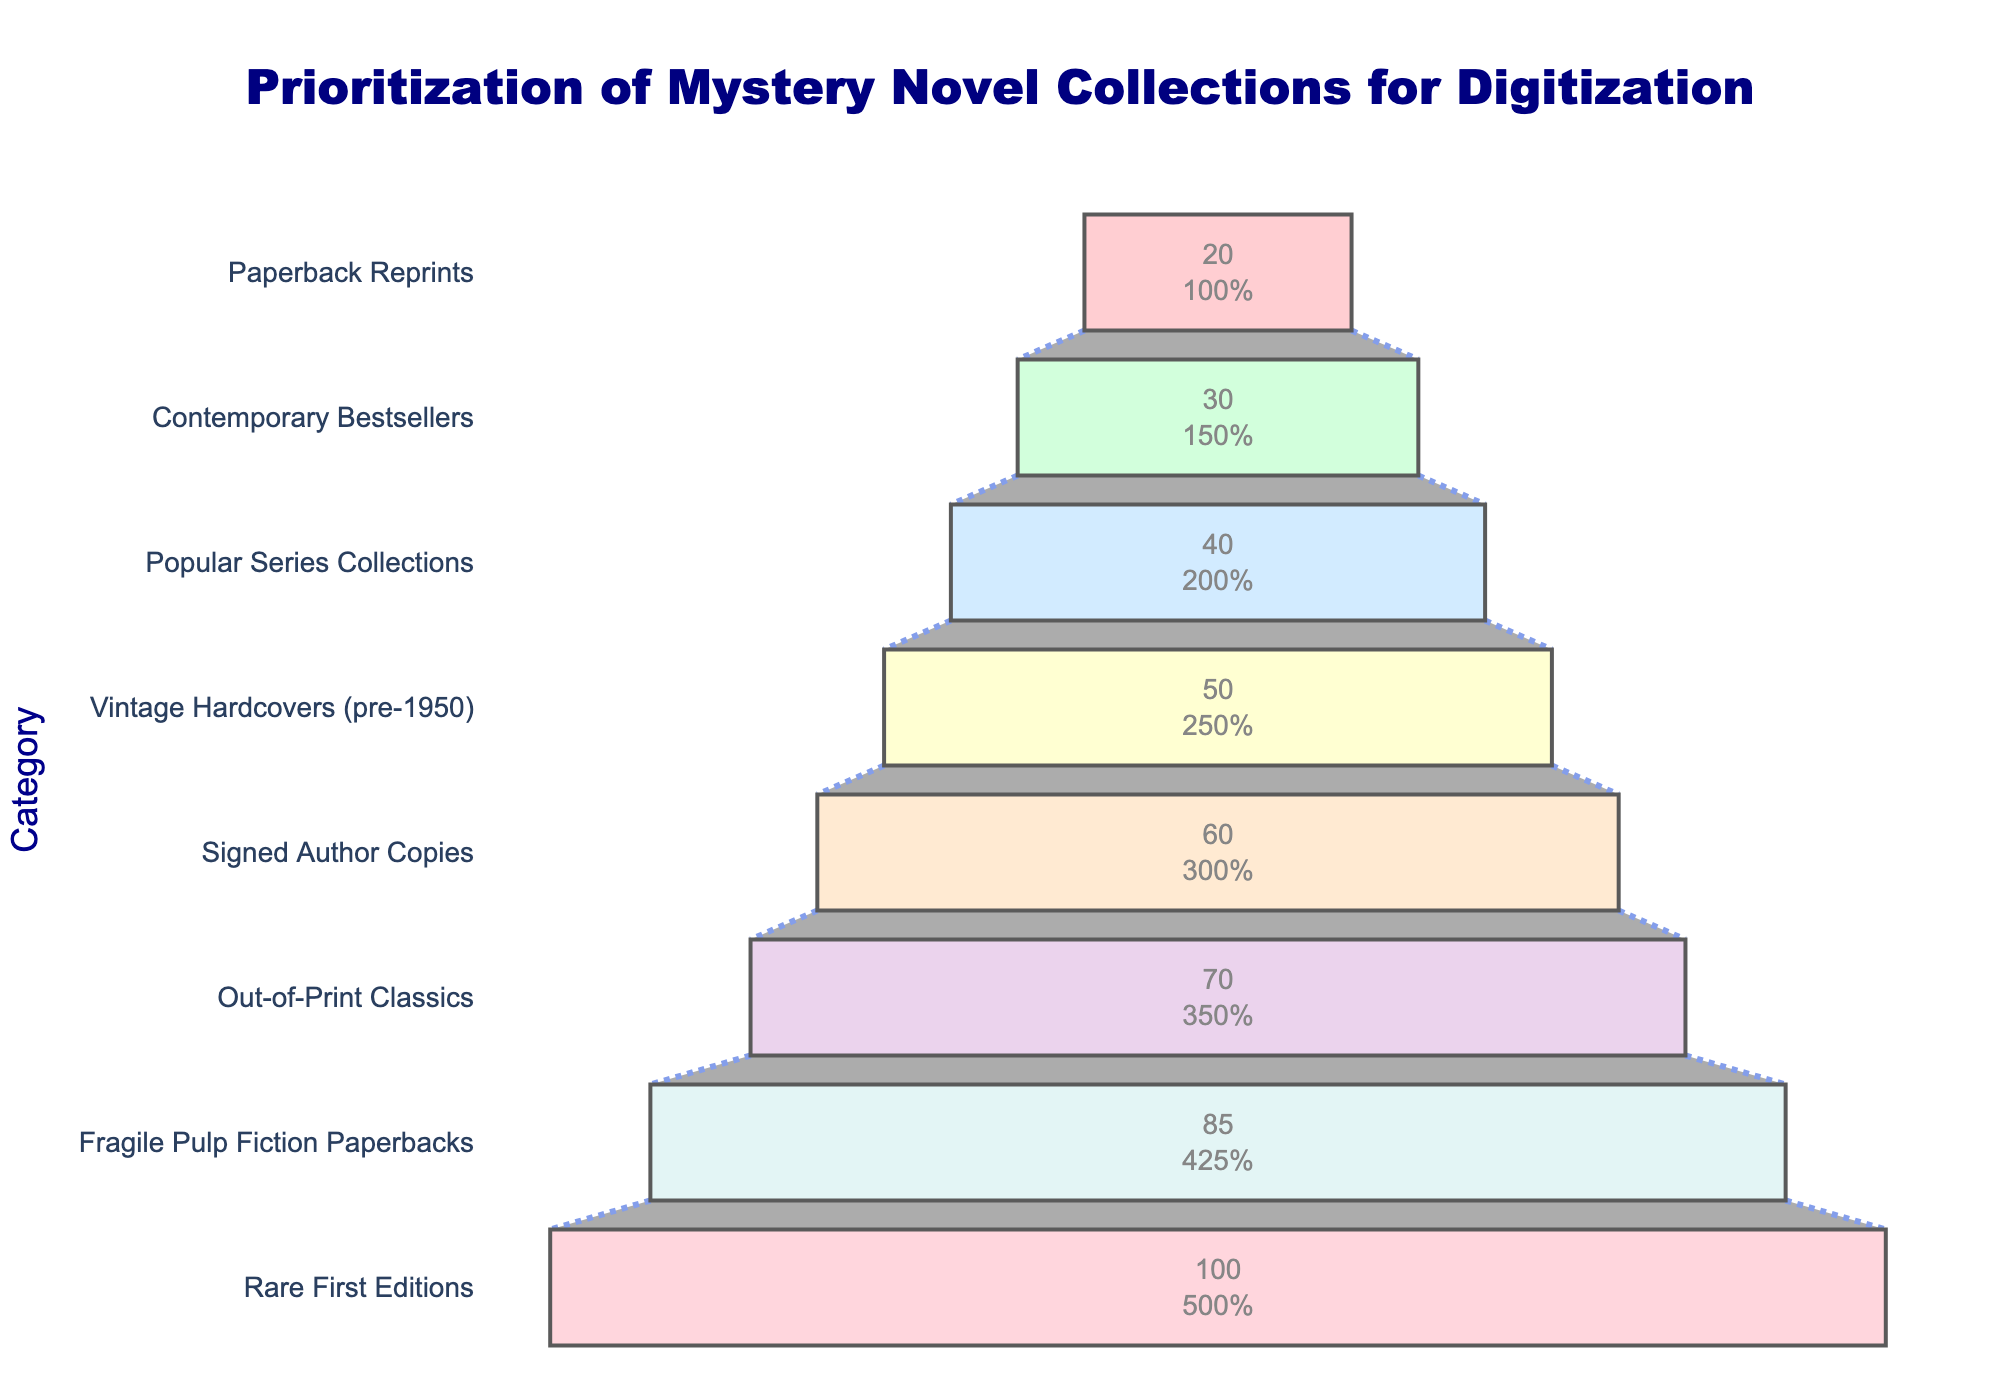What is the title of the funnel chart? The title is usually displayed at the top of the chart. Here, it is clearly written as "Prioritization of Mystery Novel Collections for Digitization."
Answer: Prioritization of Mystery Novel Collections for Digitization How many categories are prioritized in the funnel chart? The number of unique elements along the y-axis represents the number of categories. Each category corresponds to a mystery novel collection type.
Answer: Eight Which category has the highest priority score for digitization? The category at the bottom of the funnel (largest segment) with the highest priority score, clearly displayed on the x-axis.
Answer: Rare First Editions What is the priority score for Contemporary Bestsellers? Locate the segment labeled "Contemporary Bestsellers" in the funnel chart and read the corresponding priority score from the x-axis labels.
Answer: 30 Which category has a priority score of 50? Locate the segment in the funnel with an "x" value of 50 and check the corresponding "y" value, representing the category.
Answer: Vintage Hardcovers (pre-1950) Which has more priority: Signed Author Copies or Popular Series Collections, and by how much? Locate the segments for Signed Author Copies and Popular Series Collections. Compare their priority scores by subtracting the lower score from the higher score. Signed Author Copies has a score of 60, and Popular Series Collections has 40. The difference is 60 - 40.
Answer: Signed Author Copies by 20 What is the total of all priority scores combined? Add together all individual priority scores from each segment: 100 + 85 + 70 + 60 + 50 + 40 + 30 + 20.
Answer: 455 How does the priority score of Out-of-Print Classics compare to Fragile Pulp Fiction Paperbacks? Locate these two categories; Out-of-Print Classics has a score of 70, and Fragile Pulp Fiction Paperbacks has 85. Out-of-Print Classics is lower.
Answer: It is 15 points lower What's the average priority score of all the categories? Calculate the mean by adding up all priority scores (455) and dividing by the number of categories (8).
Answer: 455 / 8 = 56.875 What percentage of the total priority score does Rare First Editions constitute? Divide the Rare First Editions score (100) by the total score (455) and multiply by 100 to get the percentage: (100 / 455) * 100.
Answer: Approximately 21.98% What is the difference in the priority score between the highest and lowest priority categories? Subtract the priority score of the lowest category (Paperback Reprints, 20) from the highest category (Rare First Editions, 100): 100 - 20.
Answer: 80 